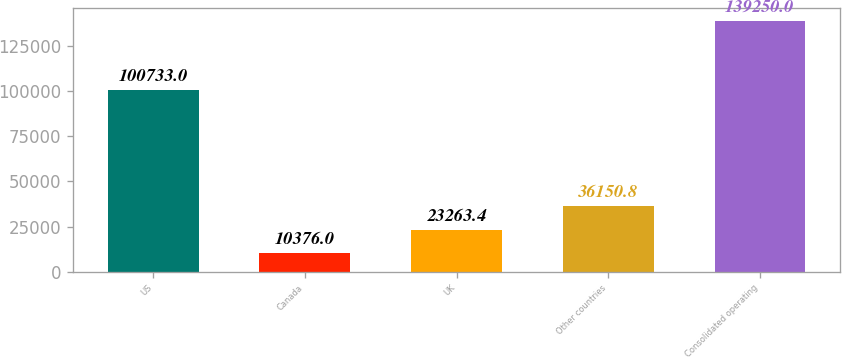Convert chart to OTSL. <chart><loc_0><loc_0><loc_500><loc_500><bar_chart><fcel>US<fcel>Canada<fcel>UK<fcel>Other countries<fcel>Consolidated operating<nl><fcel>100733<fcel>10376<fcel>23263.4<fcel>36150.8<fcel>139250<nl></chart> 